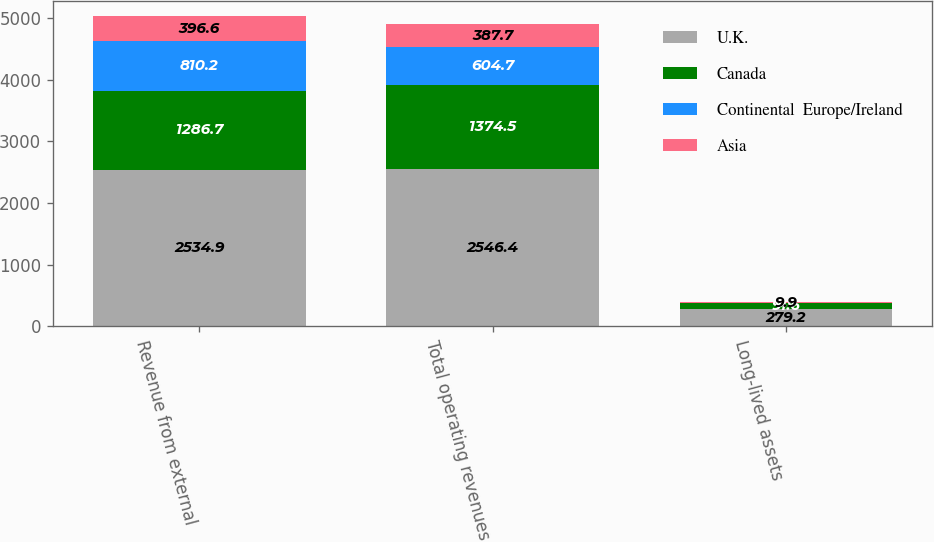Convert chart to OTSL. <chart><loc_0><loc_0><loc_500><loc_500><stacked_bar_chart><ecel><fcel>Revenue from external<fcel>Total operating revenues<fcel>Long-lived assets<nl><fcel>U.K.<fcel>2534.9<fcel>2546.4<fcel>279.2<nl><fcel>Canada<fcel>1286.7<fcel>1374.5<fcel>91.6<nl><fcel>Continental  Europe/Ireland<fcel>810.2<fcel>604.7<fcel>6.6<nl><fcel>Asia<fcel>396.6<fcel>387.7<fcel>9.9<nl></chart> 